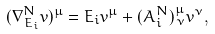Convert formula to latex. <formula><loc_0><loc_0><loc_500><loc_500>( \nabla ^ { N } _ { { E } _ { i } } { v } ) ^ { \mu } = { E } _ { i } v ^ { \mu } + ( A _ { i } ^ { N } ) ^ { \mu } _ { \, \nu } v ^ { \nu } ,</formula> 